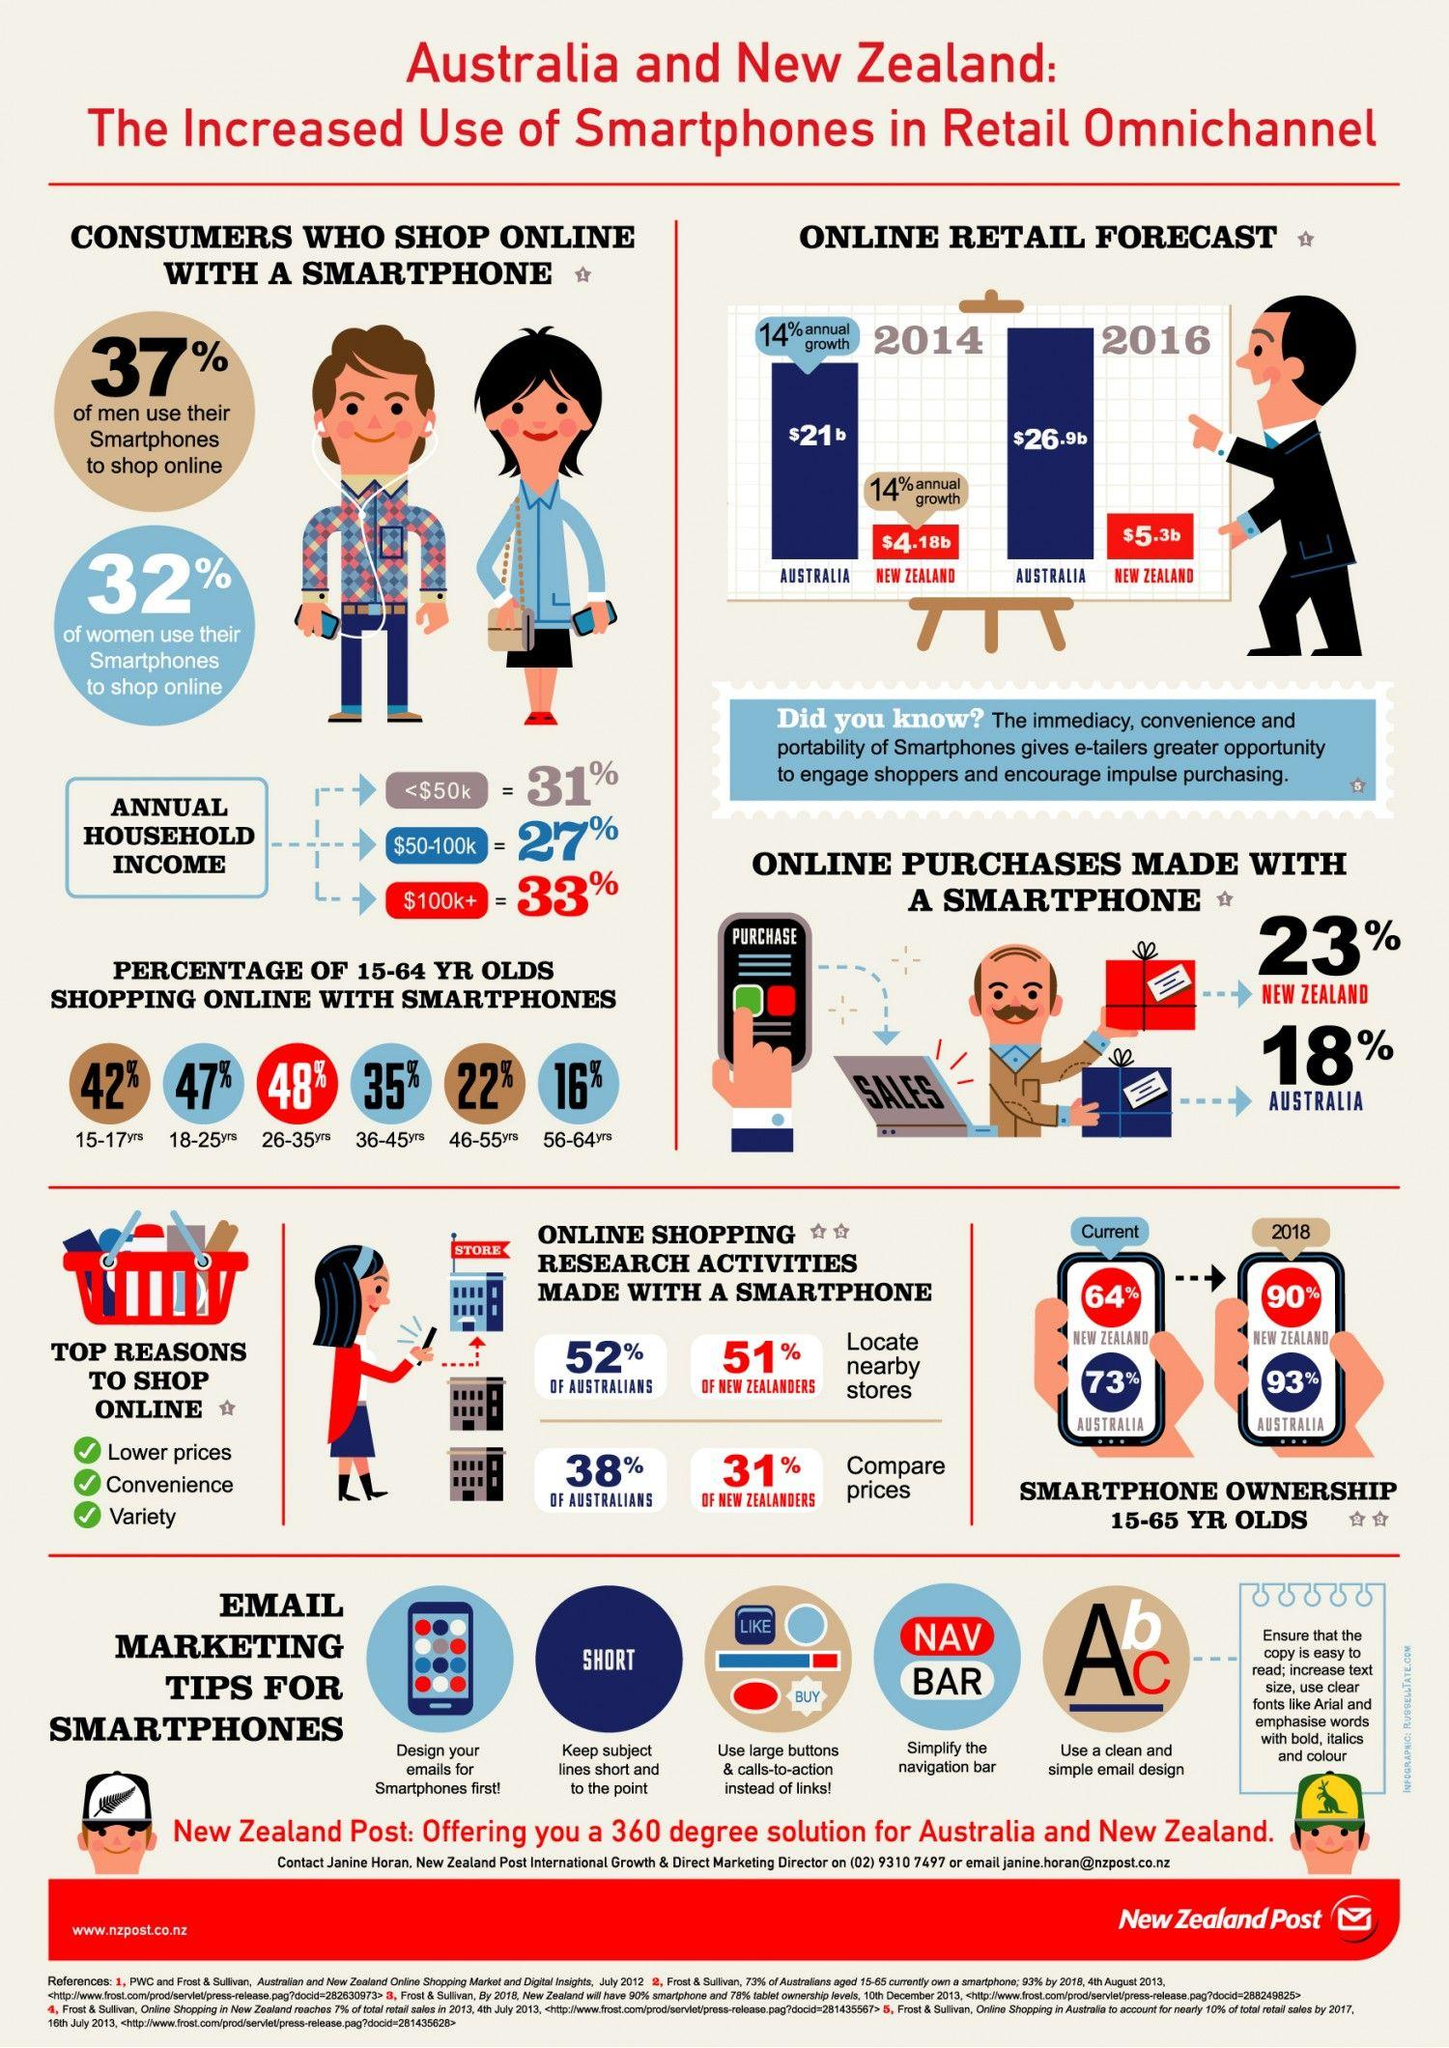Mention a couple of crucial points in this snapshot. In Australia and New Zealand, the age group that is most likely to engage in online shopping using their smartphones is individuals between 26 and 35 years old. According to the data, the age group of 56-64 year olds in Australia and New Zealand are the least interested in shopping online using their smartphones. According to a recent survey, a significant 68% of women in Australia and New Zealand do not use their smartphones to shop online. The online retail sales of smartphones in Australia in 2014 experienced a growth of 14% annually. In Australia and New Zealand, approximately 27% of consumers have an annual household income of $50,000 to $100,000. 